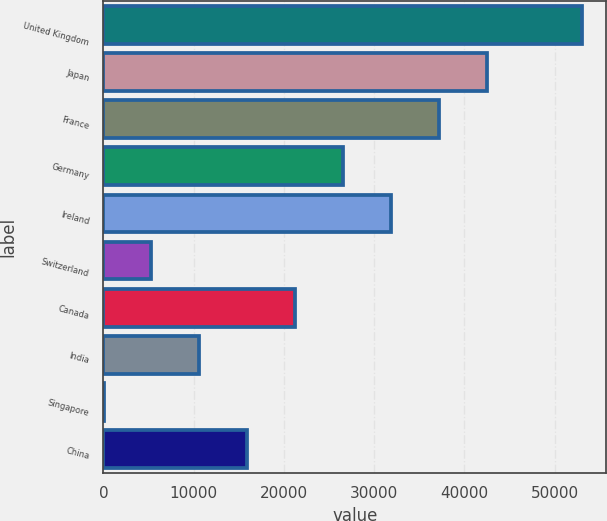Convert chart. <chart><loc_0><loc_0><loc_500><loc_500><bar_chart><fcel>United Kingdom<fcel>Japan<fcel>France<fcel>Germany<fcel>Ireland<fcel>Switzerland<fcel>Canada<fcel>India<fcel>Singapore<fcel>China<nl><fcel>53039<fcel>42438.4<fcel>37138.1<fcel>26537.5<fcel>31837.8<fcel>5336.3<fcel>21237.2<fcel>10636.6<fcel>36<fcel>15936.9<nl></chart> 